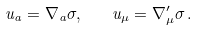Convert formula to latex. <formula><loc_0><loc_0><loc_500><loc_500>u _ { a } = \nabla _ { a } \sigma , \quad u _ { \mu } = \nabla ^ { \prime } _ { \mu } \sigma \, .</formula> 